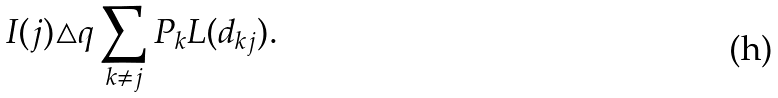<formula> <loc_0><loc_0><loc_500><loc_500>I ( j ) \triangle q \sum _ { k \neq j } P _ { k } L ( d _ { k j } ) .</formula> 